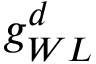Convert formula to latex. <formula><loc_0><loc_0><loc_500><loc_500>g _ { W L } ^ { d }</formula> 